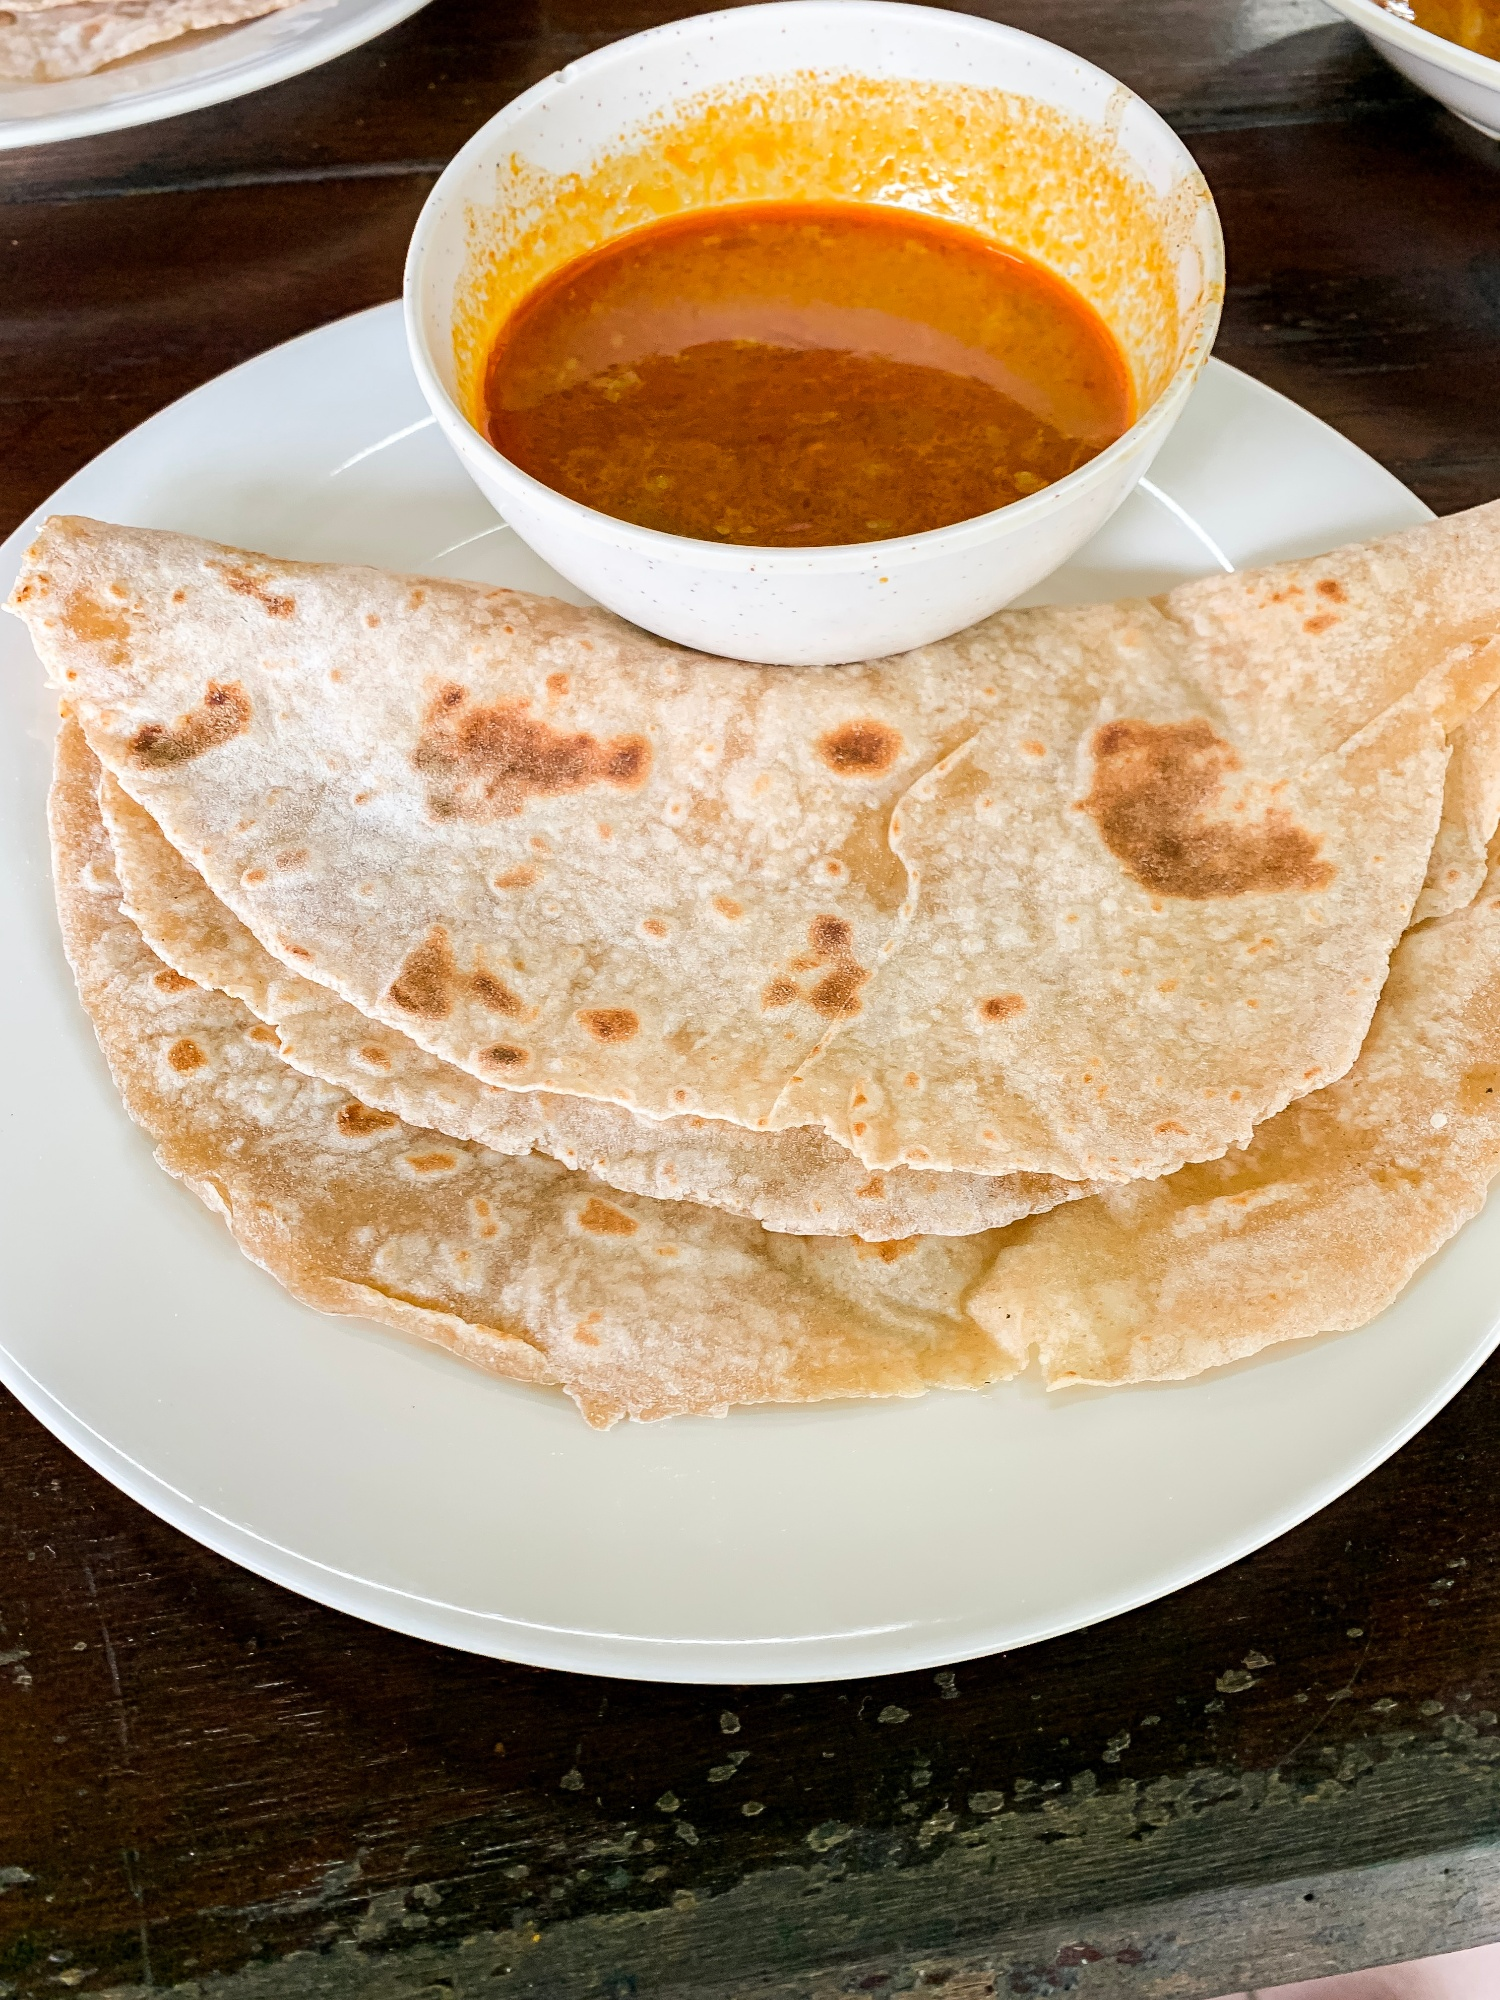What personal stories or memories does this image evoke regarding food and culture? This image evokes memories of family gatherings and communal meals. Growing up, meals with roti and curry were a daily ritual, often bringing family members together around the dining table. The process of making roti, from kneading the dough to rolling it out and cooking it on a hot griddle, was a shared activity, filled with stories and laughter. The aroma of spices simmering in a curry would fill the house, signaling that a hearty meal was about to be served. These meals weren’t just about nourishment—they were about connection, tradition, and the joy of sharing food with loved ones. Each bite of roti dipped in curry was a taste of home, culture, and the rich heritage passed down through generations. 